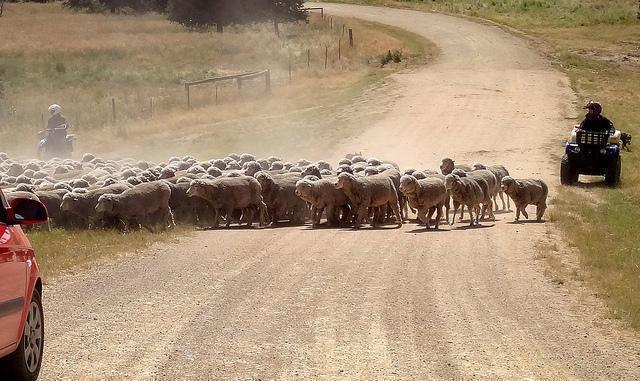Why are the sheep turning right?
Indicate the correct response and explain using: 'Answer: answer
Rationale: rationale.'
Options: Avoiding dust, eating grass, avoiding car, following motorcyclist. Answer: avoiding car.
Rationale: The sheep are turning to not be hit by the red car. 